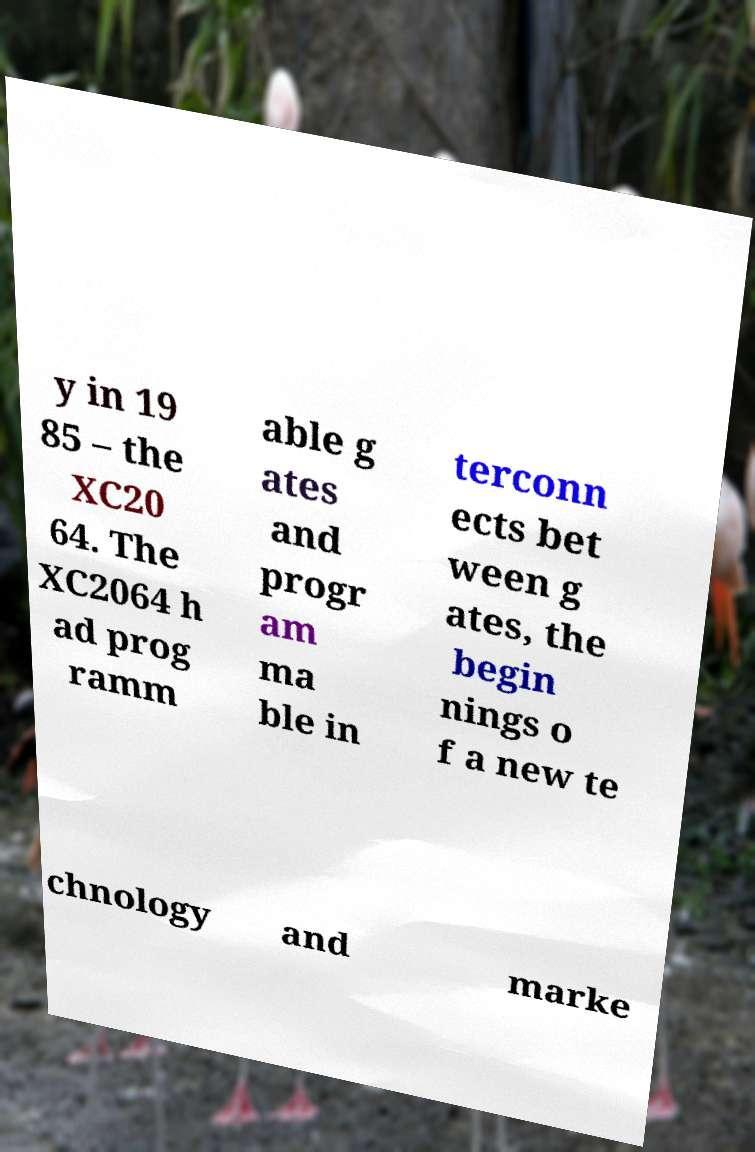Could you extract and type out the text from this image? y in 19 85 – the XC20 64. The XC2064 h ad prog ramm able g ates and progr am ma ble in terconn ects bet ween g ates, the begin nings o f a new te chnology and marke 